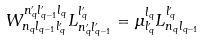Convert formula to latex. <formula><loc_0><loc_0><loc_500><loc_500>W ^ { n _ { q } ^ { \prime } l _ { q - 1 } ^ { \prime } l _ { q } } _ { n _ { q } l _ { q - 1 } l _ { q } ^ { \prime } } L _ { n _ { q } ^ { \prime } l _ { q - 1 } ^ { \prime } } ^ { l _ { q } ^ { \prime } } = \mu _ { l _ { q } ^ { \prime } } ^ { l _ { q } } L _ { n _ { q } l _ { q - 1 } } ^ { l _ { q } ^ { \prime } }</formula> 